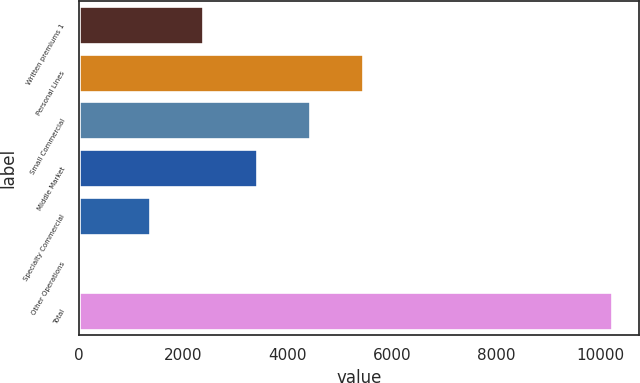Convert chart. <chart><loc_0><loc_0><loc_500><loc_500><bar_chart><fcel>Written premiums 1<fcel>Personal Lines<fcel>Small Commercial<fcel>Middle Market<fcel>Specialty Commercial<fcel>Other Operations<fcel>Total<nl><fcel>2383.4<fcel>5450.6<fcel>4428.2<fcel>3405.8<fcel>1361<fcel>7<fcel>10231<nl></chart> 